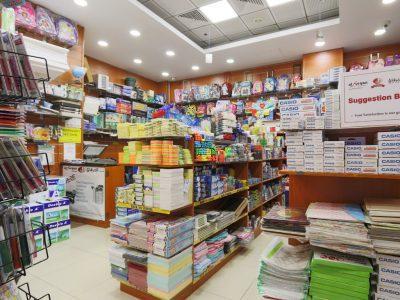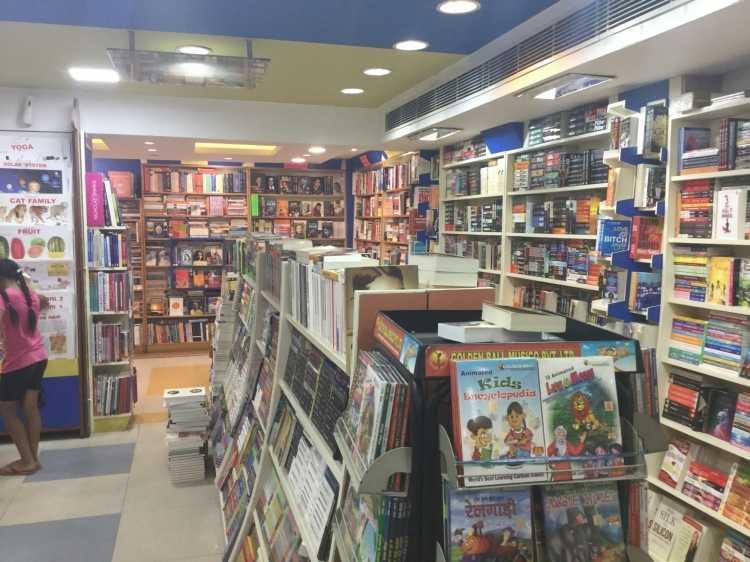The first image is the image on the left, the second image is the image on the right. For the images shown, is this caption "One image shows a seating area in a book store." true? Answer yes or no. No. 